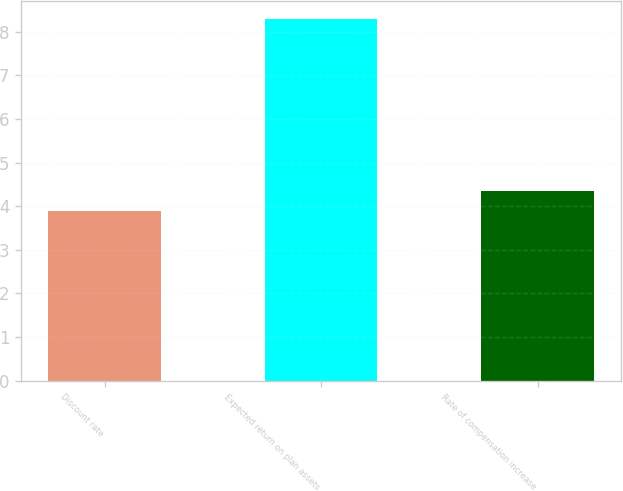Convert chart. <chart><loc_0><loc_0><loc_500><loc_500><bar_chart><fcel>Discount rate<fcel>Expected return on plan assets<fcel>Rate of compensation increase<nl><fcel>3.9<fcel>8.3<fcel>4.34<nl></chart> 